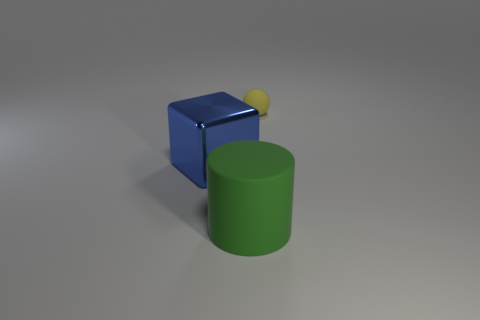Add 3 tiny red metal things. How many objects exist? 6 Subtract all cylinders. How many objects are left? 2 Add 2 metal things. How many metal things exist? 3 Subtract 1 yellow balls. How many objects are left? 2 Subtract all yellow rubber balls. Subtract all blue objects. How many objects are left? 1 Add 2 big green matte things. How many big green matte things are left? 3 